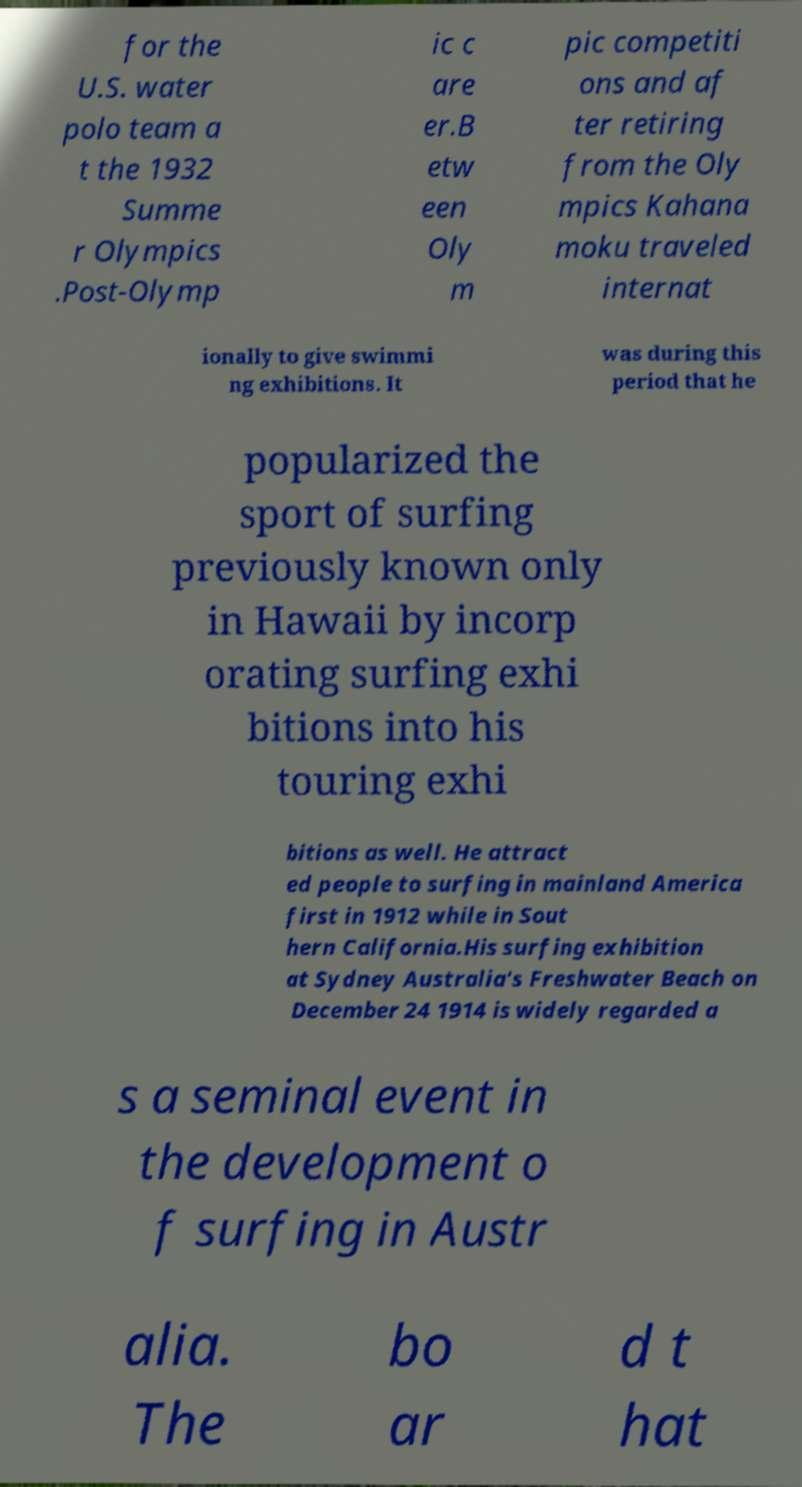Can you accurately transcribe the text from the provided image for me? for the U.S. water polo team a t the 1932 Summe r Olympics .Post-Olymp ic c are er.B etw een Oly m pic competiti ons and af ter retiring from the Oly mpics Kahana moku traveled internat ionally to give swimmi ng exhibitions. It was during this period that he popularized the sport of surfing previously known only in Hawaii by incorp orating surfing exhi bitions into his touring exhi bitions as well. He attract ed people to surfing in mainland America first in 1912 while in Sout hern California.His surfing exhibition at Sydney Australia's Freshwater Beach on December 24 1914 is widely regarded a s a seminal event in the development o f surfing in Austr alia. The bo ar d t hat 